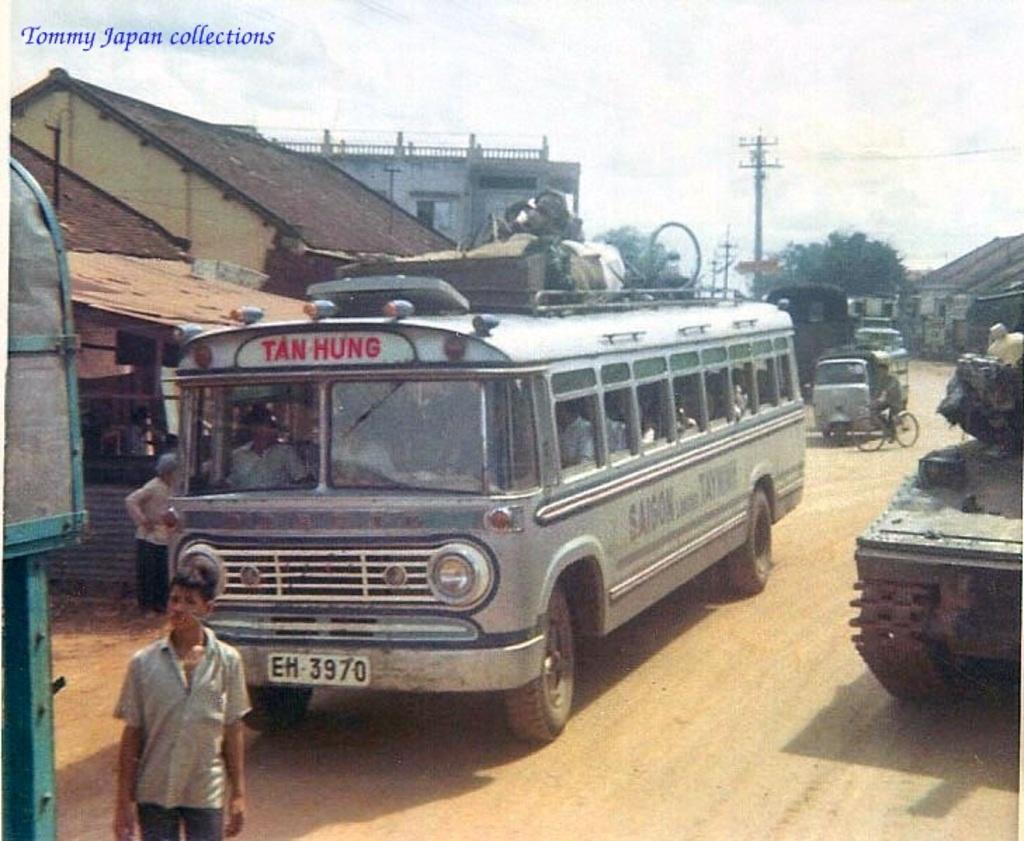Provide a one-sentence caption for the provided image. A bus, heading for Tan Hung, has a license plate which reads "EH 3970.". 